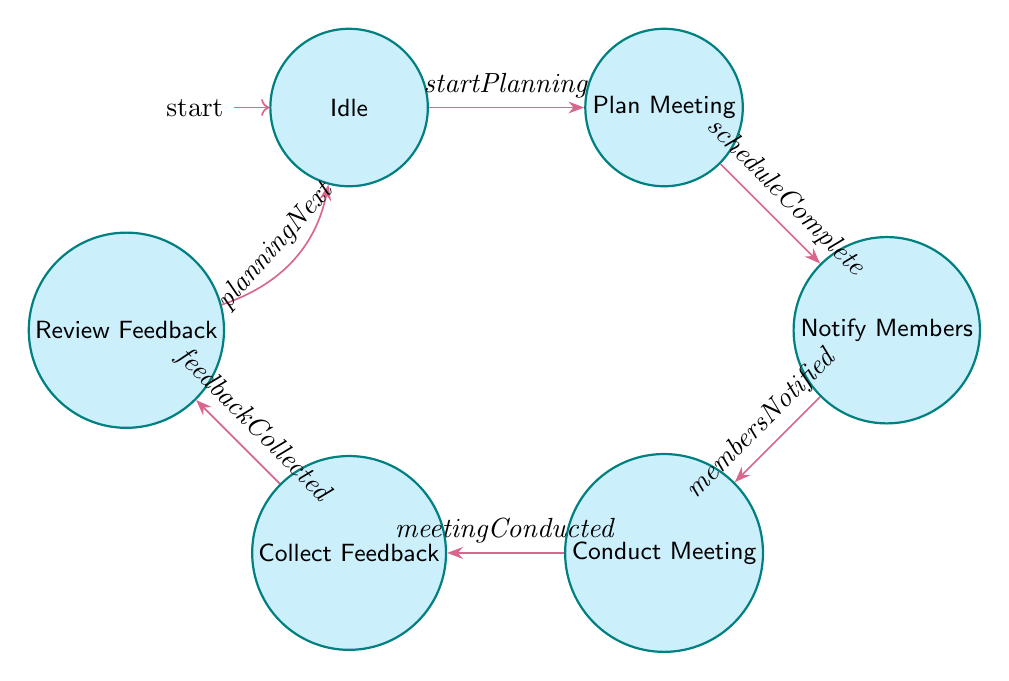What is the starting state of the diagram? The starting state is designated as "Idle," which is the initial state from where the process begins.
Answer: Idle How many nodes are present in the diagram? By counting each unique state represented as a node, we find there are a total of six nodes: Idle, Plan Meeting, Notify Members, Conduct Meeting, Collect Feedback, and Review Feedback.
Answer: Six What is the trigger for moving from "Conduct Meeting" to "Collect Feedback"? The transition from "Conduct Meeting" to "Collect Feedback" is initiated by the trigger "meetingConducted."
Answer: meetingConducted What state follows "Notify Members"? After "Notify Members," the next state reached is "Conduct Meeting" as indicated by the transition triggered by "membersNotified."
Answer: Conduct Meeting How do you return to the starting state from "Review Feedback"? To return to the starting state "Idle" from "Review Feedback," the trigger "planningNext" must be activated, facilitating the transition back.
Answer: planningNext What is the final state before returning to "Idle"? The final state before transitioning back to "Idle" is "Review Feedback," which is reached after collecting feedback indicated by the state "Collect Feedback."
Answer: Review Feedback What is the relationship between "Plan Meeting" and "Notify Members"? The relationship is a directed transition where "Plan Meeting" leads to "Notify Members," activated by the trigger "scheduleComplete."
Answer: Notify Members Which state collects feedback from members? The state responsible for collecting feedback from members is "Collect Feedback," following the conduction of the meeting.
Answer: Collect Feedback What transition proceeds from the state "Idle"? The transition proceeding from the state "Idle" is labeled "startPlanning," which leads to the next state "Plan Meeting."
Answer: Plan Meeting 